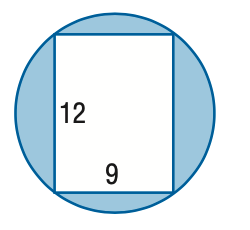Question: Find the area of the shaded region. Round to the nearest tenth.
Choices:
A. 24.7
B. 45.9
C. 68.7
D. 119.0
Answer with the letter. Answer: C 